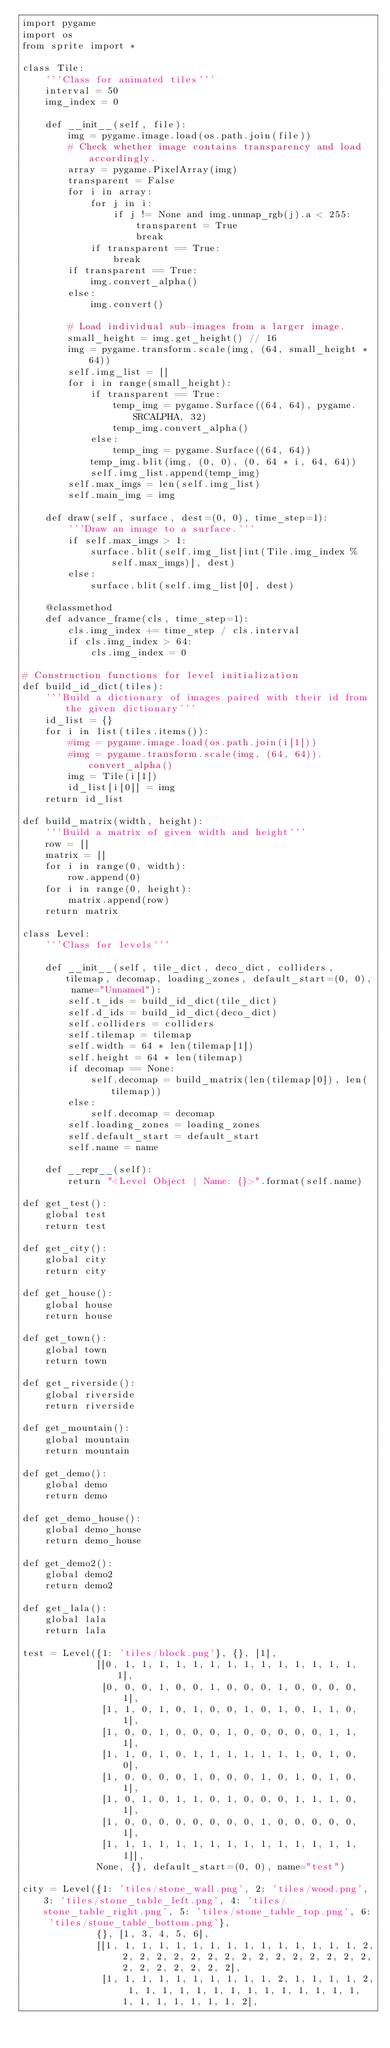Convert code to text. <code><loc_0><loc_0><loc_500><loc_500><_Python_>import pygame
import os
from sprite import *

class Tile:
    '''Class for animated tiles'''
    interval = 50
    img_index = 0

    def __init__(self, file):
        img = pygame.image.load(os.path.join(file))
        # Check whether image contains transparency and load accordingly.
        array = pygame.PixelArray(img)
        transparent = False
        for i in array:
            for j in i:
                if j != None and img.unmap_rgb(j).a < 255:
                    transparent = True
                    break
            if transparent == True:
                break
        if transparent == True:
            img.convert_alpha()
        else:
            img.convert()

        # Load individual sub-images from a larger image.
        small_height = img.get_height() // 16
        img = pygame.transform.scale(img, (64, small_height * 64))
        self.img_list = []
        for i in range(small_height):
            if transparent == True:
                temp_img = pygame.Surface((64, 64), pygame.SRCALPHA, 32)
                temp_img.convert_alpha()
            else:
                temp_img = pygame.Surface((64, 64))
            temp_img.blit(img, (0, 0), (0, 64 * i, 64, 64))
            self.img_list.append(temp_img)
        self.max_imgs = len(self.img_list)
        self.main_img = img

    def draw(self, surface, dest=(0, 0), time_step=1):
        '''Draw an image to a surface.'''
        if self.max_imgs > 1:
            surface.blit(self.img_list[int(Tile.img_index % self.max_imgs)], dest)
        else:
            surface.blit(self.img_list[0], dest)

    @classmethod
    def advance_frame(cls, time_step=1):
        cls.img_index += time_step / cls.interval
        if cls.img_index > 64:
            cls.img_index = 0

# Construction functions for level initialization
def build_id_dict(tiles):
    '''Build a dictionary of images paired with their id from the given dictionary'''
    id_list = {}
    for i in list(tiles.items()):
        #img = pygame.image.load(os.path.join(i[1]))
        #img = pygame.transform.scale(img, (64, 64)).convert_alpha()
        img = Tile(i[1])
        id_list[i[0]] = img
    return id_list

def build_matrix(width, height):
    '''Build a matrix of given width and height'''
    row = []
    matrix = []
    for i in range(0, width):
        row.append(0)
    for i in range(0, height):
        matrix.append(row)
    return matrix

class Level:
    '''Class for levels'''
    
    def __init__(self, tile_dict, deco_dict, colliders, tilemap, decomap, loading_zones, default_start=(0, 0), name="Unnamed"):
        self.t_ids = build_id_dict(tile_dict)
        self.d_ids = build_id_dict(deco_dict)
        self.colliders = colliders
        self.tilemap = tilemap
        self.width = 64 * len(tilemap[1])
        self.height = 64 * len(tilemap)
        if decomap == None:
            self.decomap = build_matrix(len(tilemap[0]), len(tilemap))
        else:
            self.decomap = decomap
        self.loading_zones = loading_zones
        self.default_start = default_start
        self.name = name

    def __repr__(self):
        return "<Level Object | Name: {}>".format(self.name)

def get_test():
    global test
    return test

def get_city():
    global city
    return city

def get_house():
    global house
    return house

def get_town():
    global town
    return town

def get_riverside():
    global riverside
    return riverside

def get_mountain():
    global mountain
    return mountain

def get_demo():
    global demo
    return demo

def get_demo_house():
    global demo_house
    return demo_house

def get_demo2():
    global demo2
    return demo2

def get_lala():
    global lala
    return lala

test = Level({1: 'tiles/block.png'}, {}, [1],
             [[0, 1, 1, 1, 1, 1, 1, 1, 1, 1, 1, 1, 1, 1, 1, 1],
              [0, 0, 0, 1, 0, 0, 1, 0, 0, 0, 1, 0, 0, 0, 0, 1],
              [1, 1, 0, 1, 0, 1, 0, 0, 1, 0, 1, 0, 1, 1, 0, 1],
              [1, 0, 0, 1, 0, 0, 0, 1, 0, 0, 0, 0, 0, 1, 1, 1],
              [1, 1, 0, 1, 0, 1, 1, 1, 1, 1, 1, 1, 0, 1, 0, 0],
              [1, 0, 0, 0, 0, 1, 0, 0, 0, 1, 0, 1, 0, 1, 0, 1],
              [1, 0, 1, 0, 1, 1, 0, 1, 0, 0, 0, 1, 1, 1, 0, 1],
              [1, 0, 0, 0, 0, 0, 0, 0, 0, 1, 0, 0, 0, 0, 0, 1],
              [1, 1, 1, 1, 1, 1, 1, 1, 1, 1, 1, 1, 1, 1, 1, 1]],
             None, {}, default_start=(0, 0), name="test")

city = Level({1: 'tiles/stone_wall.png', 2: 'tiles/wood.png', 3: 'tiles/stone_table_left.png', 4: 'tiles/stone_table_right.png', 5: 'tiles/stone_table_top.png', 6: 'tiles/stone_table_bottom.png'},
             {}, [1, 3, 4, 5, 6],
             [[1, 1, 1, 1, 1, 1, 1, 1, 1, 1, 1, 1, 1, 1, 1, 2, 2, 2, 2, 2, 2, 2, 2, 2, 2, 2, 2, 2, 2, 2, 2, 2, 2, 2, 2, 2, 2, 2],
              [1, 1, 1, 1, 1, 1, 1, 1, 1, 1, 2, 1, 1, 1, 1, 2, 1, 1, 1, 1, 1, 1, 1, 1, 1, 1, 1, 1, 1, 1, 1, 1, 1, 1, 1, 1, 1, 2],</code> 